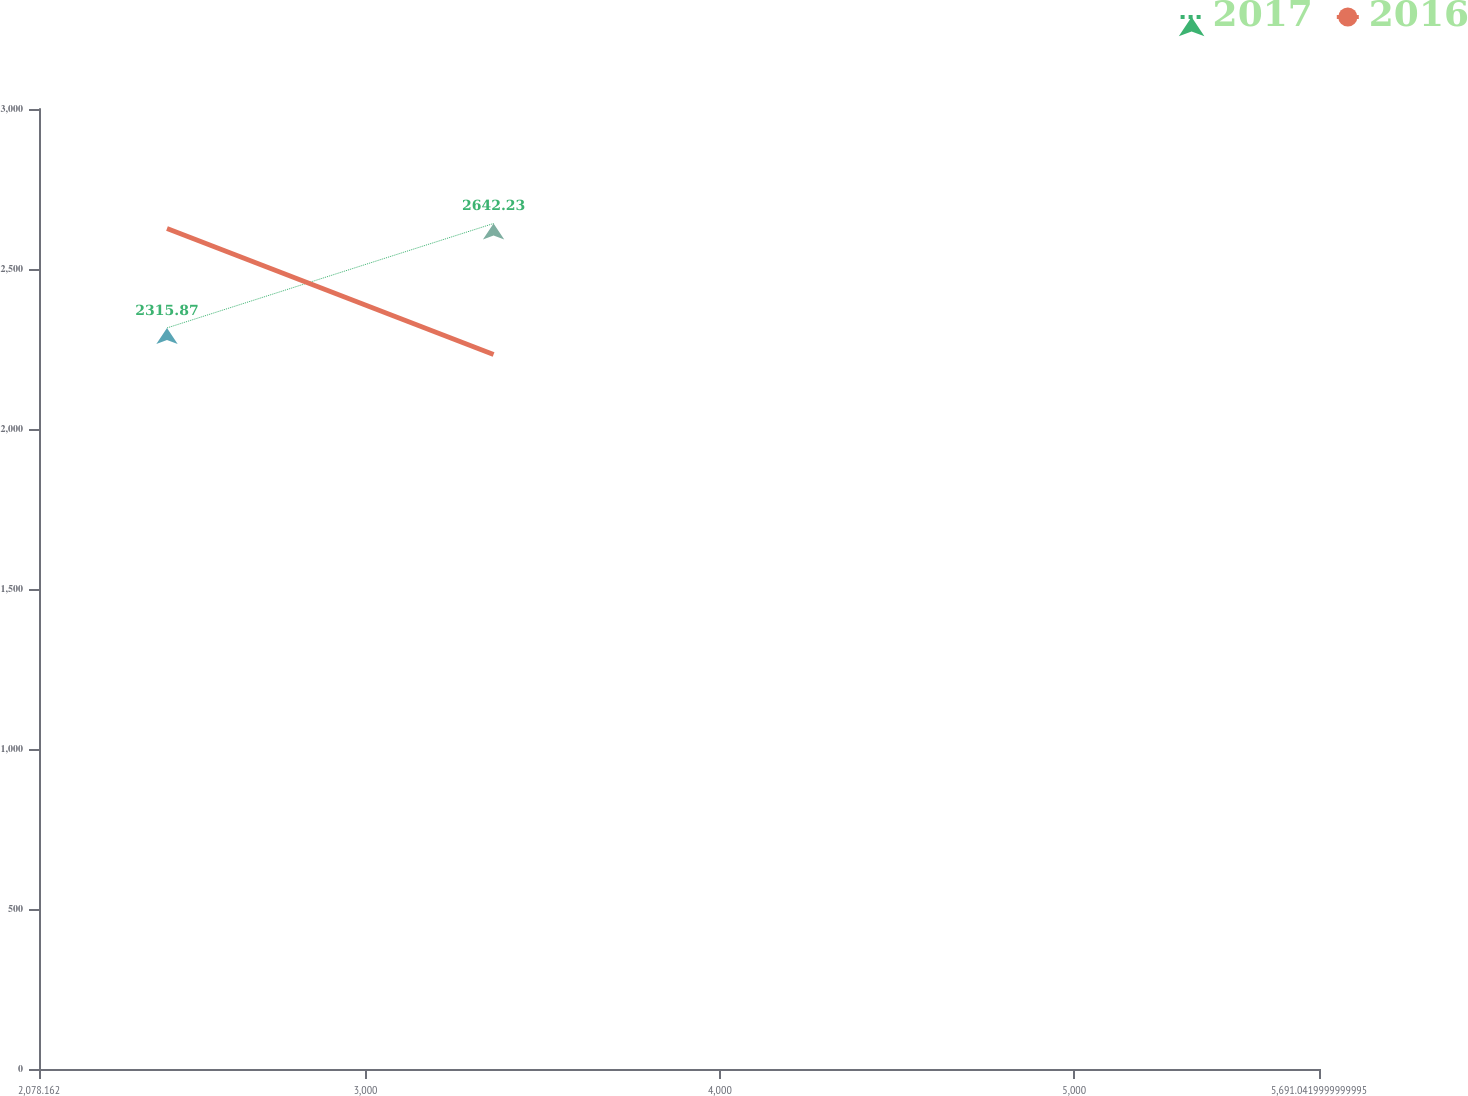Convert chart. <chart><loc_0><loc_0><loc_500><loc_500><line_chart><ecel><fcel>2017<fcel>2016<nl><fcel>2439.45<fcel>2315.87<fcel>2626.62<nl><fcel>3361.25<fcel>2642.23<fcel>2232.84<nl><fcel>6052.33<fcel>4503.23<fcel>4961.44<nl></chart> 